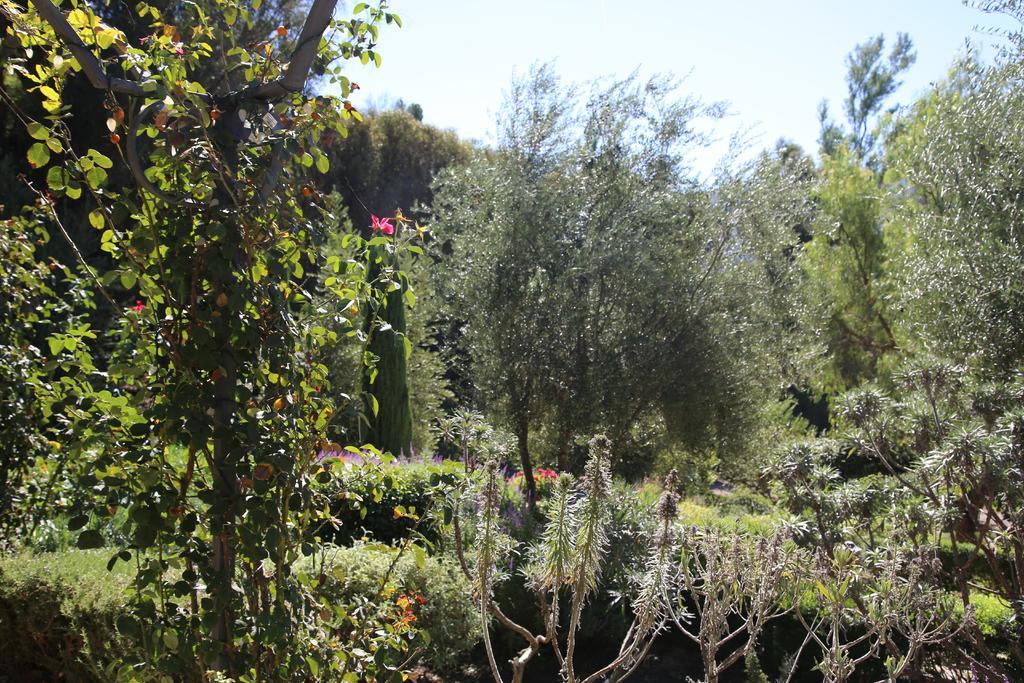Can you describe this image briefly? In this picture I can see some red flowers on the plants. In the back I can see many trees, plants and grass. At the top I can see the sky and clouds. 